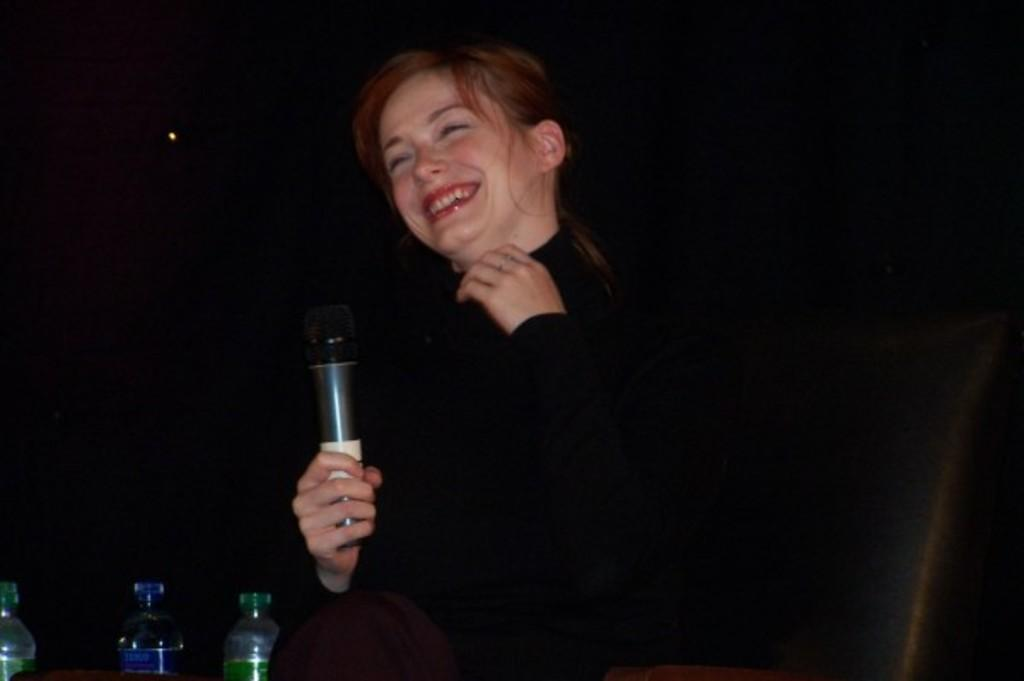Who is the main subject in the image? There is a woman in the image. What is the woman wearing? The woman is wearing a black t-shirt. What is the woman holding in the image? The woman is holding a microphone. What is the woman's position in the image? The woman is sitting on a chair. What items are in front of the woman? There are water bottles in front of the woman. What is the color of the background in the image? The background of the image is black. What type of cheese can be heard in the background of the image? There is no cheese present in the image, and therefore no sound can be heard from it. 